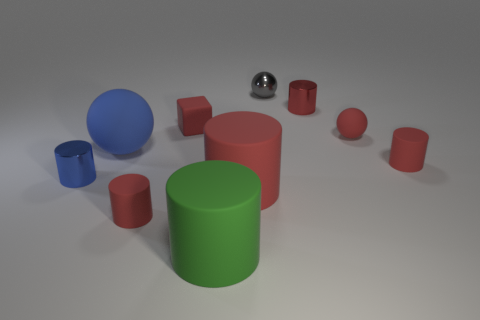Subtract all red cylinders. How many were subtracted if there are1red cylinders left? 3 Subtract all brown cubes. How many red cylinders are left? 4 Subtract all blue cylinders. How many cylinders are left? 5 Subtract all green cylinders. How many cylinders are left? 5 Subtract all green cylinders. Subtract all green balls. How many cylinders are left? 5 Subtract all cylinders. How many objects are left? 4 Add 9 rubber cubes. How many rubber cubes are left? 10 Add 3 small red metal spheres. How many small red metal spheres exist? 3 Subtract 0 gray blocks. How many objects are left? 10 Subtract all yellow shiny blocks. Subtract all red matte spheres. How many objects are left? 9 